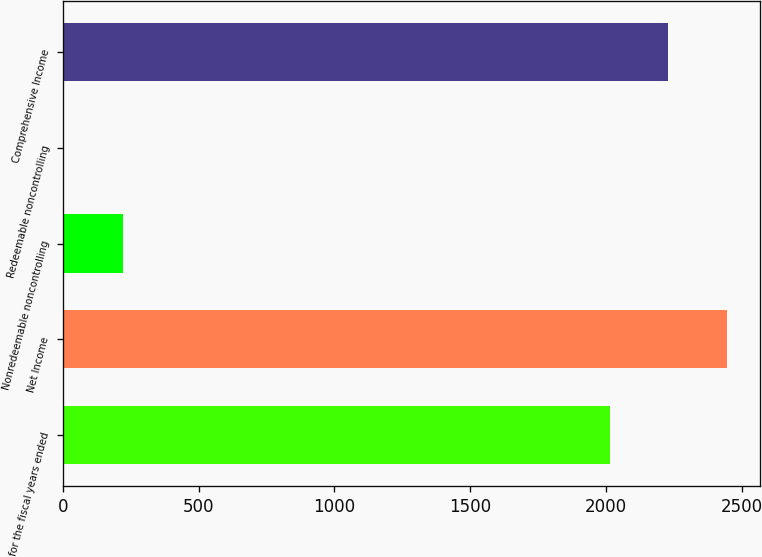Convert chart. <chart><loc_0><loc_0><loc_500><loc_500><bar_chart><fcel>for the fiscal years ended<fcel>Net Income<fcel>Nonredeemable noncontrolling<fcel>Redeemable noncontrolling<fcel>Comprehensive Income<nl><fcel>2013<fcel>2446.42<fcel>220.31<fcel>3.6<fcel>2229.71<nl></chart> 